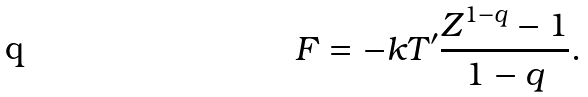Convert formula to latex. <formula><loc_0><loc_0><loc_500><loc_500>F = - k T ^ { \prime } \frac { Z ^ { 1 - q } - 1 } { 1 - q } .</formula> 